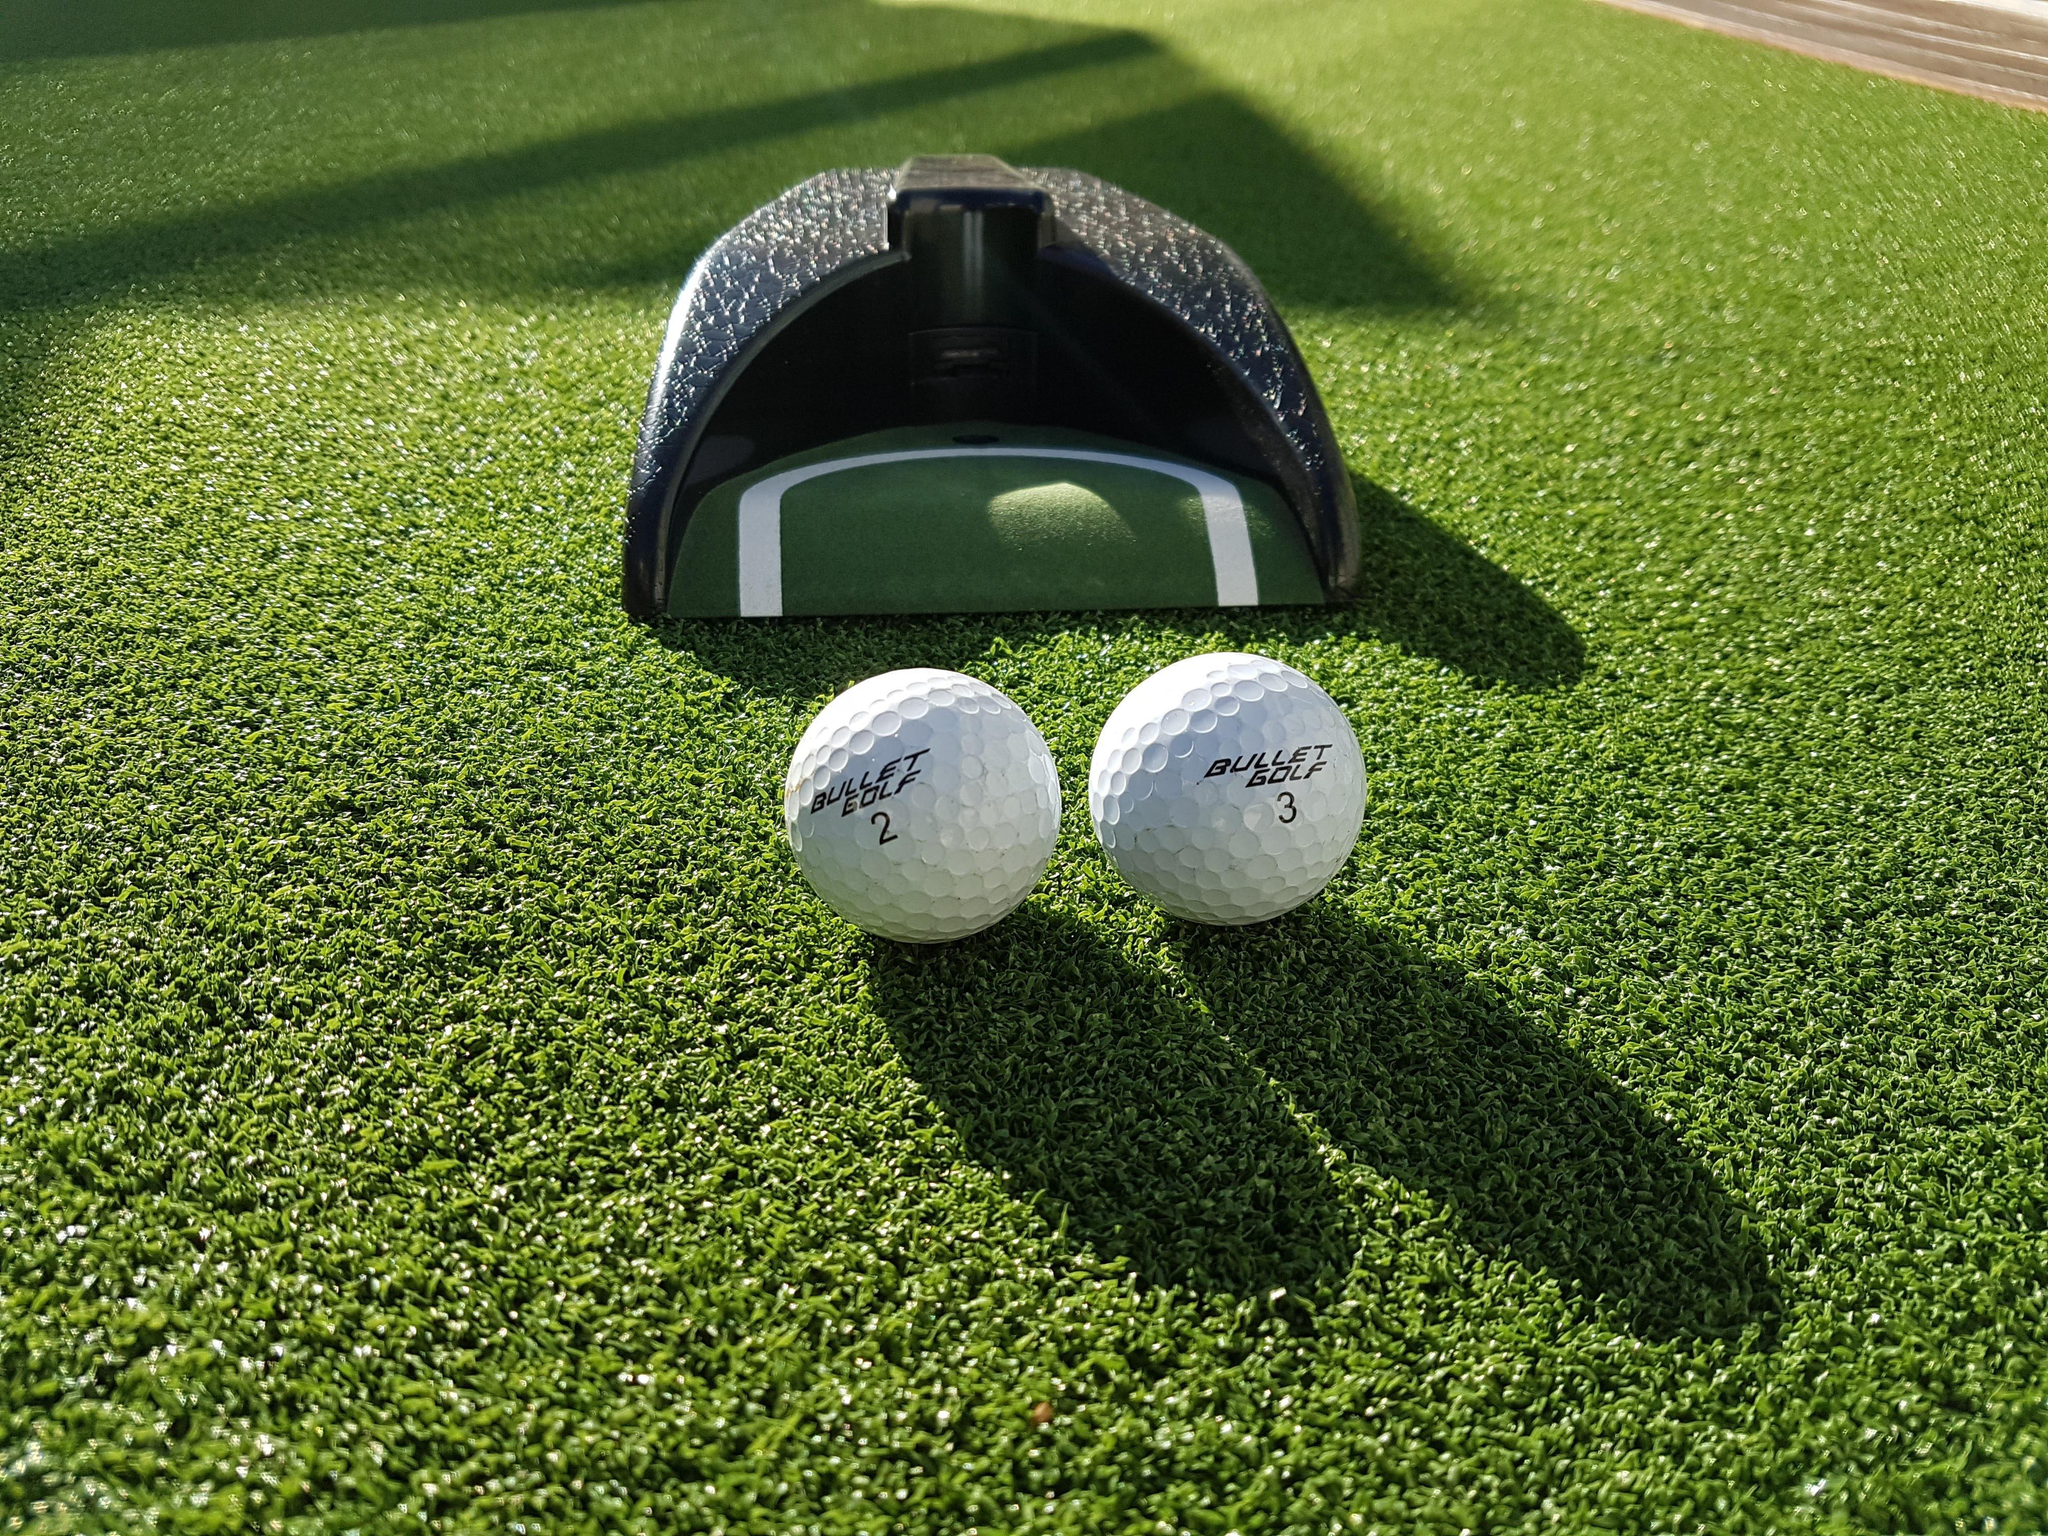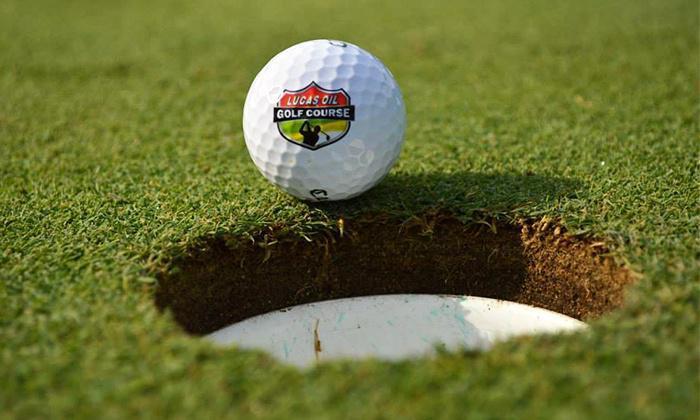The first image is the image on the left, the second image is the image on the right. Considering the images on both sides, is "In the right image, a single golf ball on a tee and part of a golf club are visible" valid? Answer yes or no. No. 